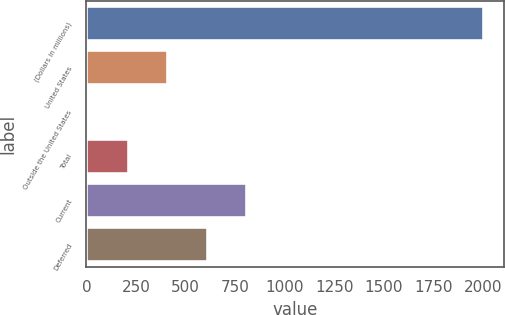Convert chart. <chart><loc_0><loc_0><loc_500><loc_500><bar_chart><fcel>(Dollars in millions)<fcel>United States<fcel>Outside the United States<fcel>Total<fcel>Current<fcel>Deferred<nl><fcel>2002<fcel>411.6<fcel>14<fcel>212.8<fcel>809.2<fcel>610.4<nl></chart> 